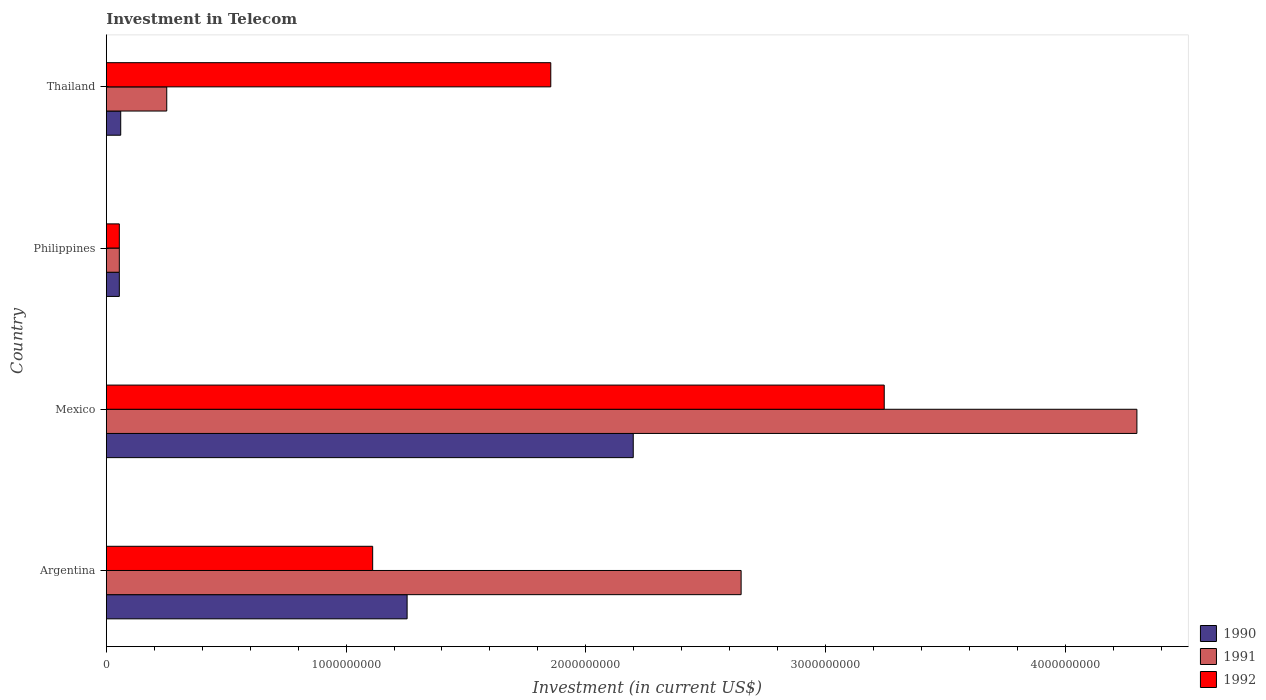How many different coloured bars are there?
Provide a succinct answer. 3. Are the number of bars per tick equal to the number of legend labels?
Your response must be concise. Yes. Are the number of bars on each tick of the Y-axis equal?
Keep it short and to the point. Yes. How many bars are there on the 3rd tick from the top?
Offer a terse response. 3. How many bars are there on the 4th tick from the bottom?
Give a very brief answer. 3. What is the label of the 2nd group of bars from the top?
Keep it short and to the point. Philippines. What is the amount invested in telecom in 1990 in Thailand?
Provide a short and direct response. 6.00e+07. Across all countries, what is the maximum amount invested in telecom in 1990?
Provide a succinct answer. 2.20e+09. Across all countries, what is the minimum amount invested in telecom in 1991?
Keep it short and to the point. 5.42e+07. In which country was the amount invested in telecom in 1990 maximum?
Your answer should be compact. Mexico. In which country was the amount invested in telecom in 1992 minimum?
Keep it short and to the point. Philippines. What is the total amount invested in telecom in 1991 in the graph?
Your response must be concise. 7.25e+09. What is the difference between the amount invested in telecom in 1991 in Argentina and that in Thailand?
Keep it short and to the point. 2.40e+09. What is the difference between the amount invested in telecom in 1991 in Argentina and the amount invested in telecom in 1990 in Thailand?
Your response must be concise. 2.59e+09. What is the average amount invested in telecom in 1990 per country?
Give a very brief answer. 8.92e+08. What is the difference between the amount invested in telecom in 1992 and amount invested in telecom in 1991 in Argentina?
Your answer should be very brief. -1.54e+09. What is the ratio of the amount invested in telecom in 1992 in Philippines to that in Thailand?
Offer a terse response. 0.03. Is the difference between the amount invested in telecom in 1992 in Mexico and Philippines greater than the difference between the amount invested in telecom in 1991 in Mexico and Philippines?
Offer a very short reply. No. What is the difference between the highest and the second highest amount invested in telecom in 1990?
Give a very brief answer. 9.43e+08. What is the difference between the highest and the lowest amount invested in telecom in 1990?
Offer a very short reply. 2.14e+09. In how many countries, is the amount invested in telecom in 1991 greater than the average amount invested in telecom in 1991 taken over all countries?
Keep it short and to the point. 2. Is the sum of the amount invested in telecom in 1992 in Argentina and Philippines greater than the maximum amount invested in telecom in 1990 across all countries?
Provide a succinct answer. No. What does the 3rd bar from the bottom in Argentina represents?
Your answer should be compact. 1992. Is it the case that in every country, the sum of the amount invested in telecom in 1991 and amount invested in telecom in 1990 is greater than the amount invested in telecom in 1992?
Make the answer very short. No. Are all the bars in the graph horizontal?
Give a very brief answer. Yes. How many countries are there in the graph?
Ensure brevity in your answer.  4. What is the difference between two consecutive major ticks on the X-axis?
Give a very brief answer. 1.00e+09. Are the values on the major ticks of X-axis written in scientific E-notation?
Offer a terse response. No. Does the graph contain grids?
Keep it short and to the point. No. Where does the legend appear in the graph?
Your response must be concise. Bottom right. How many legend labels are there?
Provide a succinct answer. 3. What is the title of the graph?
Your answer should be compact. Investment in Telecom. Does "1960" appear as one of the legend labels in the graph?
Your answer should be compact. No. What is the label or title of the X-axis?
Your answer should be compact. Investment (in current US$). What is the label or title of the Y-axis?
Offer a very short reply. Country. What is the Investment (in current US$) in 1990 in Argentina?
Provide a succinct answer. 1.25e+09. What is the Investment (in current US$) in 1991 in Argentina?
Your response must be concise. 2.65e+09. What is the Investment (in current US$) of 1992 in Argentina?
Provide a short and direct response. 1.11e+09. What is the Investment (in current US$) in 1990 in Mexico?
Make the answer very short. 2.20e+09. What is the Investment (in current US$) of 1991 in Mexico?
Your answer should be very brief. 4.30e+09. What is the Investment (in current US$) in 1992 in Mexico?
Keep it short and to the point. 3.24e+09. What is the Investment (in current US$) in 1990 in Philippines?
Offer a very short reply. 5.42e+07. What is the Investment (in current US$) of 1991 in Philippines?
Make the answer very short. 5.42e+07. What is the Investment (in current US$) of 1992 in Philippines?
Provide a succinct answer. 5.42e+07. What is the Investment (in current US$) in 1990 in Thailand?
Provide a short and direct response. 6.00e+07. What is the Investment (in current US$) of 1991 in Thailand?
Your answer should be very brief. 2.52e+08. What is the Investment (in current US$) of 1992 in Thailand?
Provide a succinct answer. 1.85e+09. Across all countries, what is the maximum Investment (in current US$) in 1990?
Offer a very short reply. 2.20e+09. Across all countries, what is the maximum Investment (in current US$) of 1991?
Give a very brief answer. 4.30e+09. Across all countries, what is the maximum Investment (in current US$) of 1992?
Make the answer very short. 3.24e+09. Across all countries, what is the minimum Investment (in current US$) of 1990?
Give a very brief answer. 5.42e+07. Across all countries, what is the minimum Investment (in current US$) in 1991?
Your answer should be compact. 5.42e+07. Across all countries, what is the minimum Investment (in current US$) of 1992?
Offer a very short reply. 5.42e+07. What is the total Investment (in current US$) in 1990 in the graph?
Your answer should be compact. 3.57e+09. What is the total Investment (in current US$) in 1991 in the graph?
Ensure brevity in your answer.  7.25e+09. What is the total Investment (in current US$) in 1992 in the graph?
Offer a very short reply. 6.26e+09. What is the difference between the Investment (in current US$) of 1990 in Argentina and that in Mexico?
Provide a succinct answer. -9.43e+08. What is the difference between the Investment (in current US$) of 1991 in Argentina and that in Mexico?
Your answer should be very brief. -1.65e+09. What is the difference between the Investment (in current US$) of 1992 in Argentina and that in Mexico?
Give a very brief answer. -2.13e+09. What is the difference between the Investment (in current US$) of 1990 in Argentina and that in Philippines?
Offer a very short reply. 1.20e+09. What is the difference between the Investment (in current US$) of 1991 in Argentina and that in Philippines?
Your response must be concise. 2.59e+09. What is the difference between the Investment (in current US$) in 1992 in Argentina and that in Philippines?
Offer a terse response. 1.06e+09. What is the difference between the Investment (in current US$) of 1990 in Argentina and that in Thailand?
Offer a very short reply. 1.19e+09. What is the difference between the Investment (in current US$) in 1991 in Argentina and that in Thailand?
Provide a short and direct response. 2.40e+09. What is the difference between the Investment (in current US$) in 1992 in Argentina and that in Thailand?
Ensure brevity in your answer.  -7.43e+08. What is the difference between the Investment (in current US$) of 1990 in Mexico and that in Philippines?
Ensure brevity in your answer.  2.14e+09. What is the difference between the Investment (in current US$) in 1991 in Mexico and that in Philippines?
Your answer should be compact. 4.24e+09. What is the difference between the Investment (in current US$) of 1992 in Mexico and that in Philippines?
Your answer should be very brief. 3.19e+09. What is the difference between the Investment (in current US$) of 1990 in Mexico and that in Thailand?
Offer a terse response. 2.14e+09. What is the difference between the Investment (in current US$) in 1991 in Mexico and that in Thailand?
Give a very brief answer. 4.05e+09. What is the difference between the Investment (in current US$) in 1992 in Mexico and that in Thailand?
Your answer should be very brief. 1.39e+09. What is the difference between the Investment (in current US$) of 1990 in Philippines and that in Thailand?
Your answer should be compact. -5.80e+06. What is the difference between the Investment (in current US$) of 1991 in Philippines and that in Thailand?
Give a very brief answer. -1.98e+08. What is the difference between the Investment (in current US$) of 1992 in Philippines and that in Thailand?
Offer a terse response. -1.80e+09. What is the difference between the Investment (in current US$) in 1990 in Argentina and the Investment (in current US$) in 1991 in Mexico?
Give a very brief answer. -3.04e+09. What is the difference between the Investment (in current US$) of 1990 in Argentina and the Investment (in current US$) of 1992 in Mexico?
Provide a succinct answer. -1.99e+09. What is the difference between the Investment (in current US$) in 1991 in Argentina and the Investment (in current US$) in 1992 in Mexico?
Your answer should be very brief. -5.97e+08. What is the difference between the Investment (in current US$) of 1990 in Argentina and the Investment (in current US$) of 1991 in Philippines?
Offer a terse response. 1.20e+09. What is the difference between the Investment (in current US$) in 1990 in Argentina and the Investment (in current US$) in 1992 in Philippines?
Provide a short and direct response. 1.20e+09. What is the difference between the Investment (in current US$) of 1991 in Argentina and the Investment (in current US$) of 1992 in Philippines?
Ensure brevity in your answer.  2.59e+09. What is the difference between the Investment (in current US$) of 1990 in Argentina and the Investment (in current US$) of 1991 in Thailand?
Offer a very short reply. 1.00e+09. What is the difference between the Investment (in current US$) of 1990 in Argentina and the Investment (in current US$) of 1992 in Thailand?
Offer a terse response. -5.99e+08. What is the difference between the Investment (in current US$) in 1991 in Argentina and the Investment (in current US$) in 1992 in Thailand?
Ensure brevity in your answer.  7.94e+08. What is the difference between the Investment (in current US$) of 1990 in Mexico and the Investment (in current US$) of 1991 in Philippines?
Offer a very short reply. 2.14e+09. What is the difference between the Investment (in current US$) in 1990 in Mexico and the Investment (in current US$) in 1992 in Philippines?
Provide a succinct answer. 2.14e+09. What is the difference between the Investment (in current US$) of 1991 in Mexico and the Investment (in current US$) of 1992 in Philippines?
Your response must be concise. 4.24e+09. What is the difference between the Investment (in current US$) of 1990 in Mexico and the Investment (in current US$) of 1991 in Thailand?
Your answer should be compact. 1.95e+09. What is the difference between the Investment (in current US$) of 1990 in Mexico and the Investment (in current US$) of 1992 in Thailand?
Provide a succinct answer. 3.44e+08. What is the difference between the Investment (in current US$) in 1991 in Mexico and the Investment (in current US$) in 1992 in Thailand?
Give a very brief answer. 2.44e+09. What is the difference between the Investment (in current US$) of 1990 in Philippines and the Investment (in current US$) of 1991 in Thailand?
Give a very brief answer. -1.98e+08. What is the difference between the Investment (in current US$) in 1990 in Philippines and the Investment (in current US$) in 1992 in Thailand?
Offer a very short reply. -1.80e+09. What is the difference between the Investment (in current US$) of 1991 in Philippines and the Investment (in current US$) of 1992 in Thailand?
Ensure brevity in your answer.  -1.80e+09. What is the average Investment (in current US$) of 1990 per country?
Keep it short and to the point. 8.92e+08. What is the average Investment (in current US$) in 1991 per country?
Make the answer very short. 1.81e+09. What is the average Investment (in current US$) of 1992 per country?
Give a very brief answer. 1.57e+09. What is the difference between the Investment (in current US$) of 1990 and Investment (in current US$) of 1991 in Argentina?
Offer a terse response. -1.39e+09. What is the difference between the Investment (in current US$) of 1990 and Investment (in current US$) of 1992 in Argentina?
Make the answer very short. 1.44e+08. What is the difference between the Investment (in current US$) of 1991 and Investment (in current US$) of 1992 in Argentina?
Ensure brevity in your answer.  1.54e+09. What is the difference between the Investment (in current US$) of 1990 and Investment (in current US$) of 1991 in Mexico?
Provide a short and direct response. -2.10e+09. What is the difference between the Investment (in current US$) in 1990 and Investment (in current US$) in 1992 in Mexico?
Your answer should be compact. -1.05e+09. What is the difference between the Investment (in current US$) in 1991 and Investment (in current US$) in 1992 in Mexico?
Offer a very short reply. 1.05e+09. What is the difference between the Investment (in current US$) in 1990 and Investment (in current US$) in 1991 in Philippines?
Offer a very short reply. 0. What is the difference between the Investment (in current US$) of 1991 and Investment (in current US$) of 1992 in Philippines?
Provide a short and direct response. 0. What is the difference between the Investment (in current US$) in 1990 and Investment (in current US$) in 1991 in Thailand?
Ensure brevity in your answer.  -1.92e+08. What is the difference between the Investment (in current US$) in 1990 and Investment (in current US$) in 1992 in Thailand?
Your answer should be compact. -1.79e+09. What is the difference between the Investment (in current US$) of 1991 and Investment (in current US$) of 1992 in Thailand?
Make the answer very short. -1.60e+09. What is the ratio of the Investment (in current US$) of 1990 in Argentina to that in Mexico?
Provide a short and direct response. 0.57. What is the ratio of the Investment (in current US$) of 1991 in Argentina to that in Mexico?
Provide a short and direct response. 0.62. What is the ratio of the Investment (in current US$) in 1992 in Argentina to that in Mexico?
Give a very brief answer. 0.34. What is the ratio of the Investment (in current US$) in 1990 in Argentina to that in Philippines?
Your answer should be compact. 23.15. What is the ratio of the Investment (in current US$) of 1991 in Argentina to that in Philippines?
Ensure brevity in your answer.  48.86. What is the ratio of the Investment (in current US$) in 1992 in Argentina to that in Philippines?
Your answer should be compact. 20.5. What is the ratio of the Investment (in current US$) in 1990 in Argentina to that in Thailand?
Offer a very short reply. 20.91. What is the ratio of the Investment (in current US$) of 1991 in Argentina to that in Thailand?
Ensure brevity in your answer.  10.51. What is the ratio of the Investment (in current US$) of 1992 in Argentina to that in Thailand?
Ensure brevity in your answer.  0.6. What is the ratio of the Investment (in current US$) of 1990 in Mexico to that in Philippines?
Your answer should be compact. 40.55. What is the ratio of the Investment (in current US$) of 1991 in Mexico to that in Philippines?
Keep it short and to the point. 79.32. What is the ratio of the Investment (in current US$) of 1992 in Mexico to that in Philippines?
Give a very brief answer. 59.87. What is the ratio of the Investment (in current US$) in 1990 in Mexico to that in Thailand?
Your answer should be very brief. 36.63. What is the ratio of the Investment (in current US$) in 1991 in Mexico to that in Thailand?
Ensure brevity in your answer.  17.06. What is the ratio of the Investment (in current US$) in 1992 in Mexico to that in Thailand?
Offer a terse response. 1.75. What is the ratio of the Investment (in current US$) of 1990 in Philippines to that in Thailand?
Your answer should be compact. 0.9. What is the ratio of the Investment (in current US$) in 1991 in Philippines to that in Thailand?
Make the answer very short. 0.22. What is the ratio of the Investment (in current US$) in 1992 in Philippines to that in Thailand?
Your response must be concise. 0.03. What is the difference between the highest and the second highest Investment (in current US$) of 1990?
Your answer should be very brief. 9.43e+08. What is the difference between the highest and the second highest Investment (in current US$) in 1991?
Your response must be concise. 1.65e+09. What is the difference between the highest and the second highest Investment (in current US$) of 1992?
Provide a succinct answer. 1.39e+09. What is the difference between the highest and the lowest Investment (in current US$) of 1990?
Offer a very short reply. 2.14e+09. What is the difference between the highest and the lowest Investment (in current US$) in 1991?
Provide a short and direct response. 4.24e+09. What is the difference between the highest and the lowest Investment (in current US$) in 1992?
Give a very brief answer. 3.19e+09. 